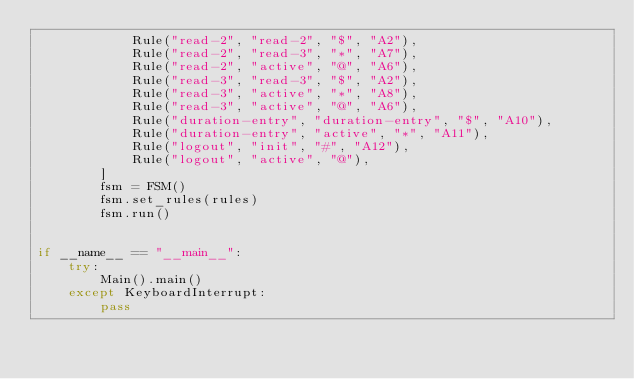Convert code to text. <code><loc_0><loc_0><loc_500><loc_500><_Python_>            Rule("read-2", "read-2", "$", "A2"),
            Rule("read-2", "read-3", "*", "A7"),
            Rule("read-2", "active", "@", "A6"),
            Rule("read-3", "read-3", "$", "A2"),
            Rule("read-3", "active", "*", "A8"),
            Rule("read-3", "active", "@", "A6"),
            Rule("duration-entry", "duration-entry", "$", "A10"),
            Rule("duration-entry", "active", "*", "A11"),
            Rule("logout", "init", "#", "A12"),
            Rule("logout", "active", "@"),
        ]
        fsm = FSM()
        fsm.set_rules(rules)
        fsm.run()


if __name__ == "__main__":
    try:
        Main().main()
    except KeyboardInterrupt:
        pass
</code> 